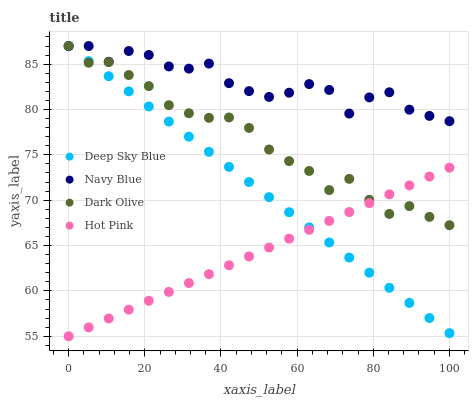Does Hot Pink have the minimum area under the curve?
Answer yes or no. Yes. Does Navy Blue have the maximum area under the curve?
Answer yes or no. Yes. Does Dark Olive have the minimum area under the curve?
Answer yes or no. No. Does Dark Olive have the maximum area under the curve?
Answer yes or no. No. Is Hot Pink the smoothest?
Answer yes or no. Yes. Is Navy Blue the roughest?
Answer yes or no. Yes. Is Dark Olive the smoothest?
Answer yes or no. No. Is Dark Olive the roughest?
Answer yes or no. No. Does Hot Pink have the lowest value?
Answer yes or no. Yes. Does Dark Olive have the lowest value?
Answer yes or no. No. Does Deep Sky Blue have the highest value?
Answer yes or no. Yes. Does Hot Pink have the highest value?
Answer yes or no. No. Is Hot Pink less than Navy Blue?
Answer yes or no. Yes. Is Navy Blue greater than Hot Pink?
Answer yes or no. Yes. Does Navy Blue intersect Dark Olive?
Answer yes or no. Yes. Is Navy Blue less than Dark Olive?
Answer yes or no. No. Is Navy Blue greater than Dark Olive?
Answer yes or no. No. Does Hot Pink intersect Navy Blue?
Answer yes or no. No. 